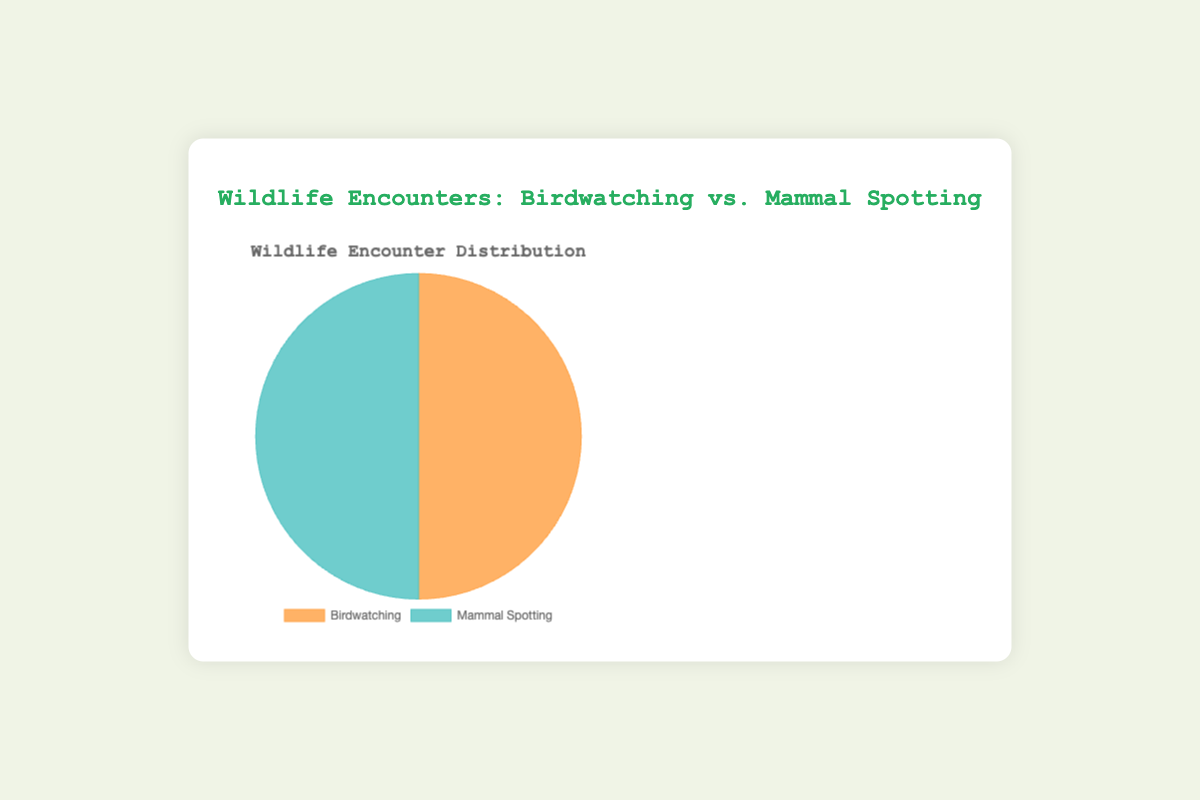What are the two categories shown in the pie chart? The pie chart labels represent two categories: 'Birdwatching' and 'Mammal Spotting.'
Answer: Birdwatching and Mammal Spotting Which category has a higher total frequency of wildlife encounters? The pie chart compares the total frequencies of the two categories. By observing the chart, 'Birdwatching' and 'Mammal Spotting' frequencies can be compared directly. Birdwatching (100) is less than Mammal Spotting (100).
Answer: They are equal Which category has a larger slice in the pie chart? By quickly observing the visual, each category's slice size represents its frequency. 'Birdwatching' and 'Mammal Spotting' slices are the same size, indicating equal frequency.
Answer: They are equal Calculate the frequency difference between the categories if 'Birdwatching' had an additional 10 encounters. Initially, both categories have equal frequencies (100 each). By adding 10 to 'Birdwatching,' it becomes 110. The difference 110-100 equals 10.
Answer: 10 If the total frequency for 'Mammal Spotting' doubled, what would the new pie chart slice proportions be? Initially, 'Mammal Spotting' has a frequency of 100. If it doubles, the new frequency becomes 200. The new total is 300. Thus, the proportions are 'Birdwatching': 100/300 and 'Mammal Spotting': 200/300.
Answer: Birdwatching: 1/3, Mammal Spotting: 2/3 Which slice color corresponds to 'Mammal Spotting'? Observing the legend or chart coloring, 'Birdwatching' is represented by an orangish tone, and 'Mammal Spotting' is represented by turquoise.
Answer: Turquoise By how much does the frequency of 'American Robin' exceed 'Red-tailed Hawk'? Comparing the frequencies, 'American Robin' is 45 and 'Red-tailed Hawk' is 35. Subtracting 45 - 35 gives the difference.
Answer: 10 If 'American Robin' and 'Eastern Gray Squirrel' were combined into a new category, how many encounters would it total? Adding 'American Robin' frequency (45) to 'Eastern Gray Squirrel' frequency (50), the total becomes 95.
Answer: 95 Is the frequency of 'White-tailed Deer' less than 'Red-tailed Hawk + Bald Eagle'? The frequency of 'White-tailed Deer' is 30. Summing 'Red-tailed Hawk' (35) and 'Bald Eagle' (20) gives 55. Since 30 < 55, the condition holds true.
Answer: Yes 